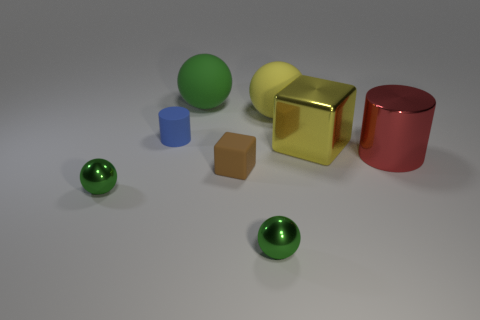Is the number of tiny green objects left of the tiny cube the same as the number of green metal things?
Provide a succinct answer. No. There is a cylinder that is behind the big block; does it have the same color as the large block?
Your answer should be very brief. No. What material is the large thing that is right of the brown object and left of the yellow cube?
Keep it short and to the point. Rubber. Are there any metallic objects to the left of the green sphere that is behind the large cylinder?
Your response must be concise. Yes. Is the large green sphere made of the same material as the big red cylinder?
Your response must be concise. No. There is a rubber thing that is both to the left of the rubber block and behind the blue rubber cylinder; what is its shape?
Provide a short and direct response. Sphere. What is the size of the matte cylinder that is on the left side of the green thing on the right side of the tiny brown matte thing?
Offer a terse response. Small. What number of other things are the same shape as the yellow metallic object?
Give a very brief answer. 1. Is the color of the small matte cylinder the same as the big cube?
Your answer should be very brief. No. Is there any other thing that has the same shape as the large green object?
Provide a succinct answer. Yes. 